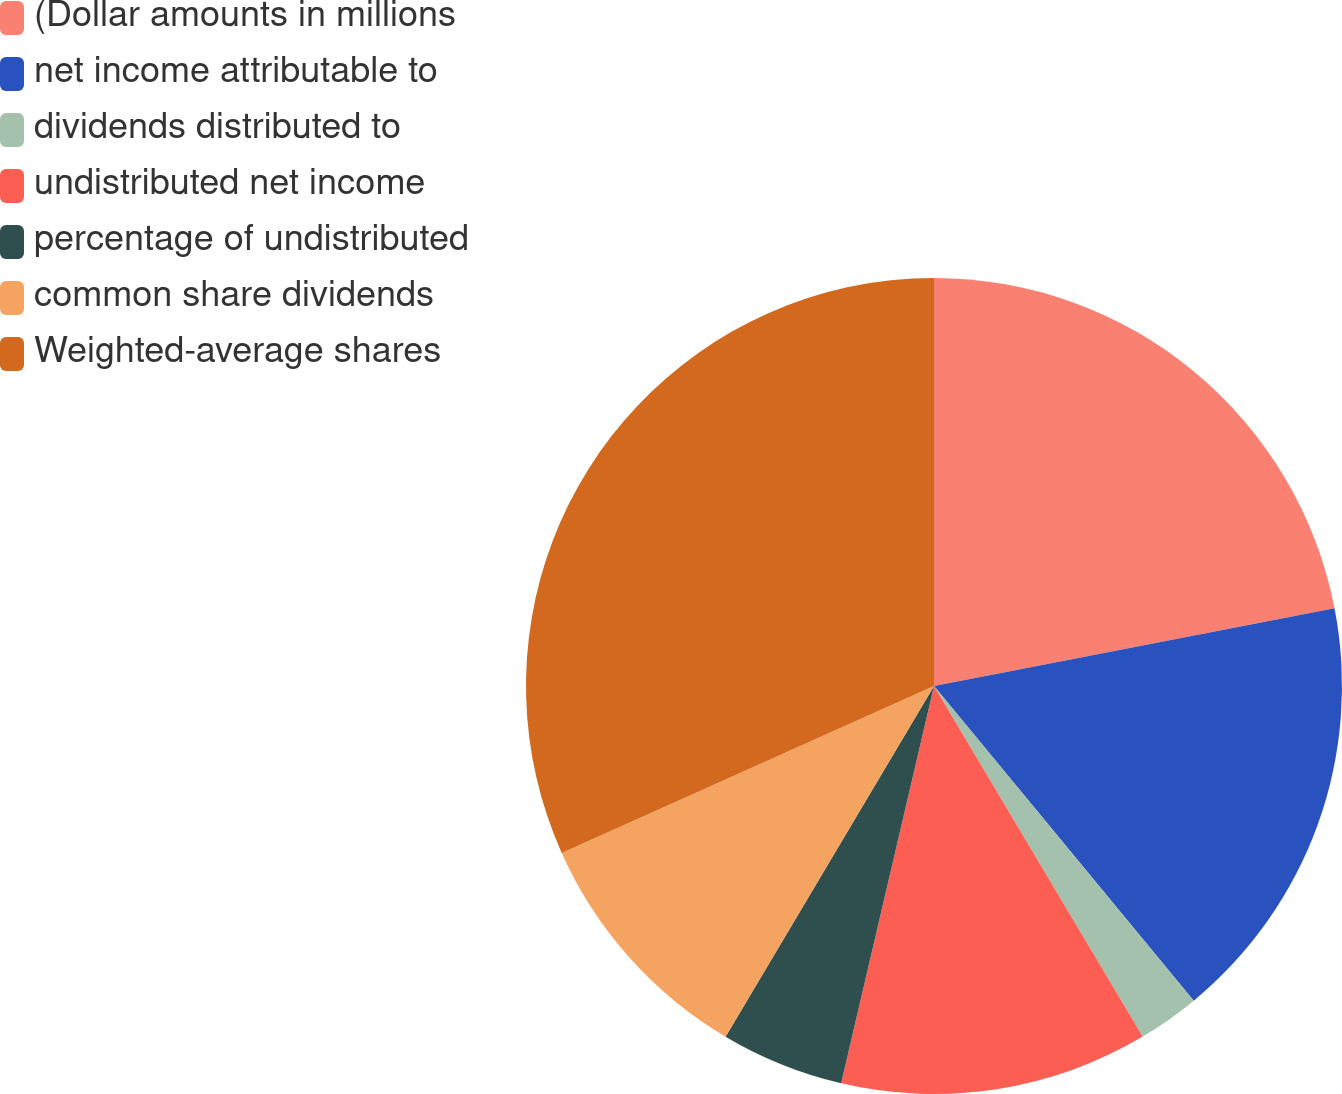Convert chart to OTSL. <chart><loc_0><loc_0><loc_500><loc_500><pie_chart><fcel>(Dollar amounts in millions<fcel>net income attributable to<fcel>dividends distributed to<fcel>undistributed net income<fcel>percentage of undistributed<fcel>common share dividends<fcel>Weighted-average shares<nl><fcel>21.95%<fcel>17.07%<fcel>2.44%<fcel>12.2%<fcel>4.88%<fcel>9.76%<fcel>31.71%<nl></chart> 